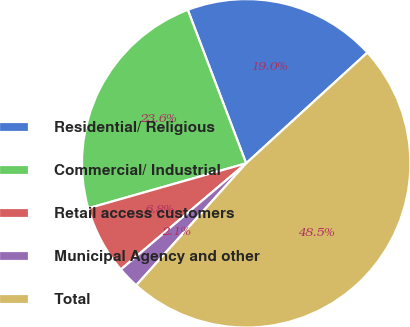Convert chart. <chart><loc_0><loc_0><loc_500><loc_500><pie_chart><fcel>Residential/ Religious<fcel>Commercial/ Industrial<fcel>Retail access customers<fcel>Municipal Agency and other<fcel>Total<nl><fcel>19.0%<fcel>23.63%<fcel>6.77%<fcel>2.14%<fcel>48.46%<nl></chart> 